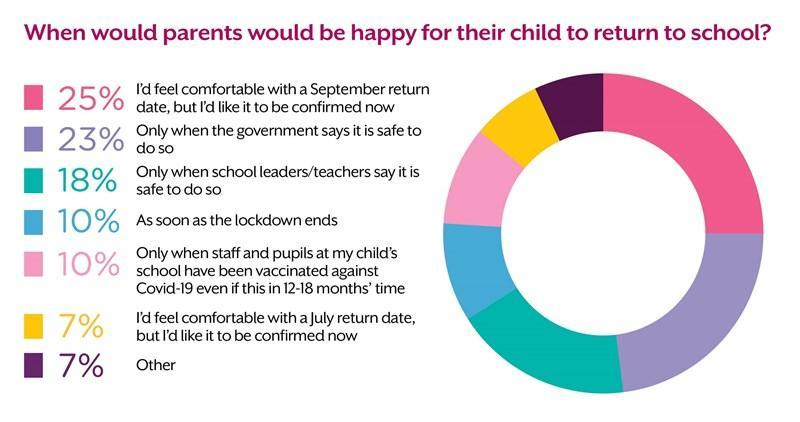What is the total % of parents who feel the children can return home as soon as lockdown ends or when staff and pupils at the child's school have been vaccinated against COVID-19
Answer the question with a short phrase. 20 By which people are the parents highlighted in yellow colour comfortable as the return date July How many % are ready to send their children to school when the school leaders say so or when the government says it is safe so 41 WHat % of parents are willing to wait for 12-18 months time 10% 